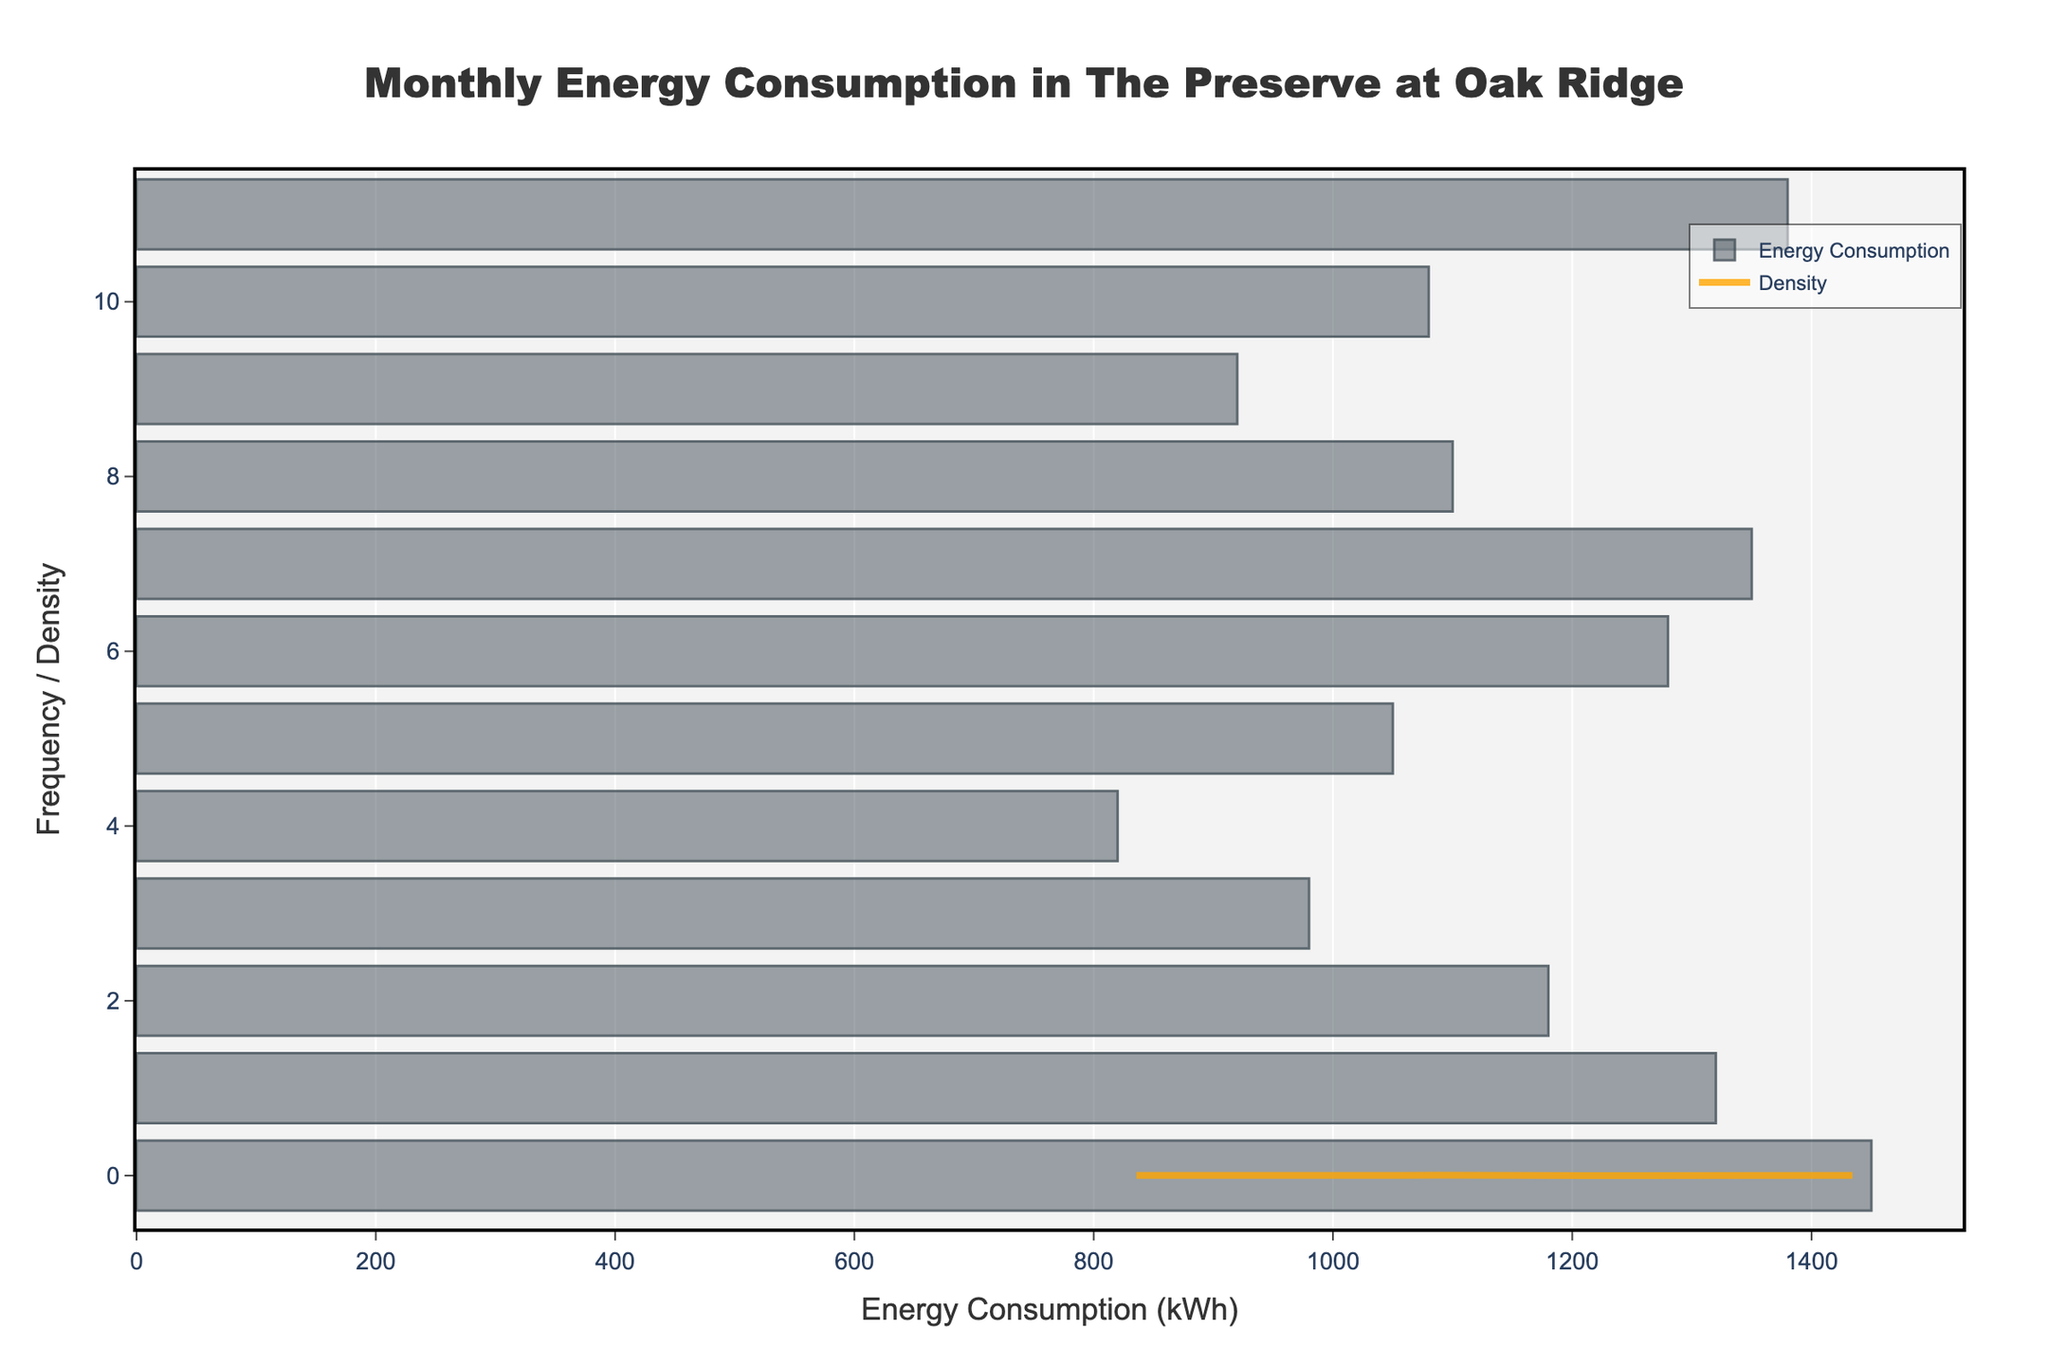What's the title of the figure? The title is typically displayed prominently at the top of the figure. Looking at the given figure, the title is shown as: 'Monthly Energy Consumption in The Preserve at Oak Ridge'.
Answer: Monthly Energy Consumption in The Preserve at Oak Ridge What is the label for the x-axis? The label for the x-axis is commonly situated below the axis itself. In this figure, it reads 'Energy Consumption (kWh)'.
Answer: Energy Consumption (kWh) What is the label for the y-axis? The label for the y-axis is often located to the left of the axis. Here, it is 'Frequency / Density'.
Answer: Frequency / Density Which month shows the highest energy consumption? By observing the height of the bars in the histogram, the bar corresponding to December appears to be the highest, indicating maximum energy consumption.
Answer: December During which months is the energy consumption below 1000 kWh? By assessing the bars in the histogram that fall below 1000 kWh, the months with lower energy consumption are April, May, and October.
Answer: April, May, October How many months have an energy consumption above 1200 kWh? By counting the bars that are above the 1200 kWh mark in the histogram, it shows three months. These months are January, August, and December.
Answer: 3 What is the approximate density value at 1050 kWh? By tracing the density curve (KDE) that intersects the line at 1050 kWh, the approximate density value can be inferred. It is around 0.0015.
Answer: Approximately 0.0015 Which months have almost the same energy consumption? Comparing the height of the bars in the histogram, February and August have very similar energy consumption values, both close to each other.
Answer: February, August What can you infer about summer energy consumption from the figure? Observing the histogram, which represents monthly energy consumption, it's evident that summer months (June, July, August) have relatively high energy consumption with August being notably high.
Answer: High energy consumption Does any month have a significantly higher density compared to its neighboring months? By examining the KDE curve, December stands out with a noticeably higher density compared to the months around it, signifying higher energy usage.
Answer: December 